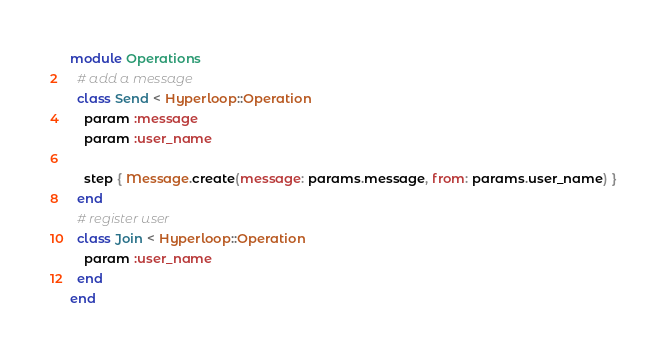<code> <loc_0><loc_0><loc_500><loc_500><_Ruby_>module Operations
  # add a message
  class Send < Hyperloop::Operation
    param :message
    param :user_name

    step { Message.create(message: params.message, from: params.user_name) }
  end
  # register user
  class Join < Hyperloop::Operation
    param :user_name
  end
end
</code> 